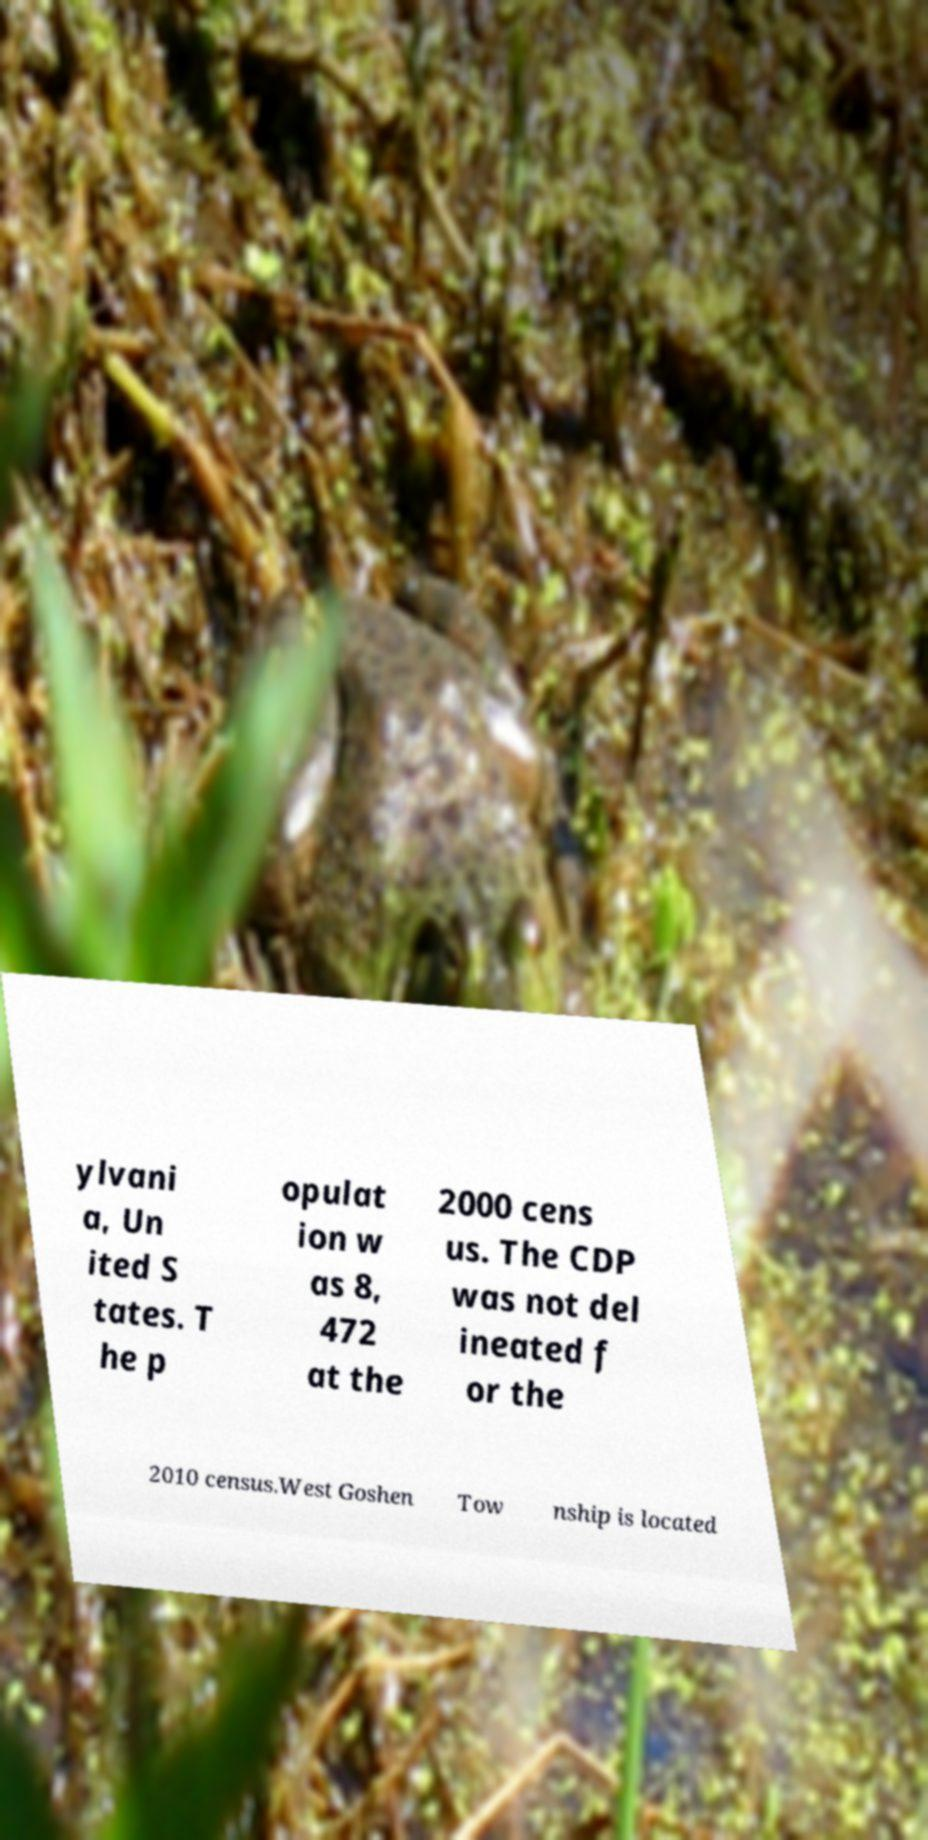Please read and relay the text visible in this image. What does it say? ylvani a, Un ited S tates. T he p opulat ion w as 8, 472 at the 2000 cens us. The CDP was not del ineated f or the 2010 census.West Goshen Tow nship is located 